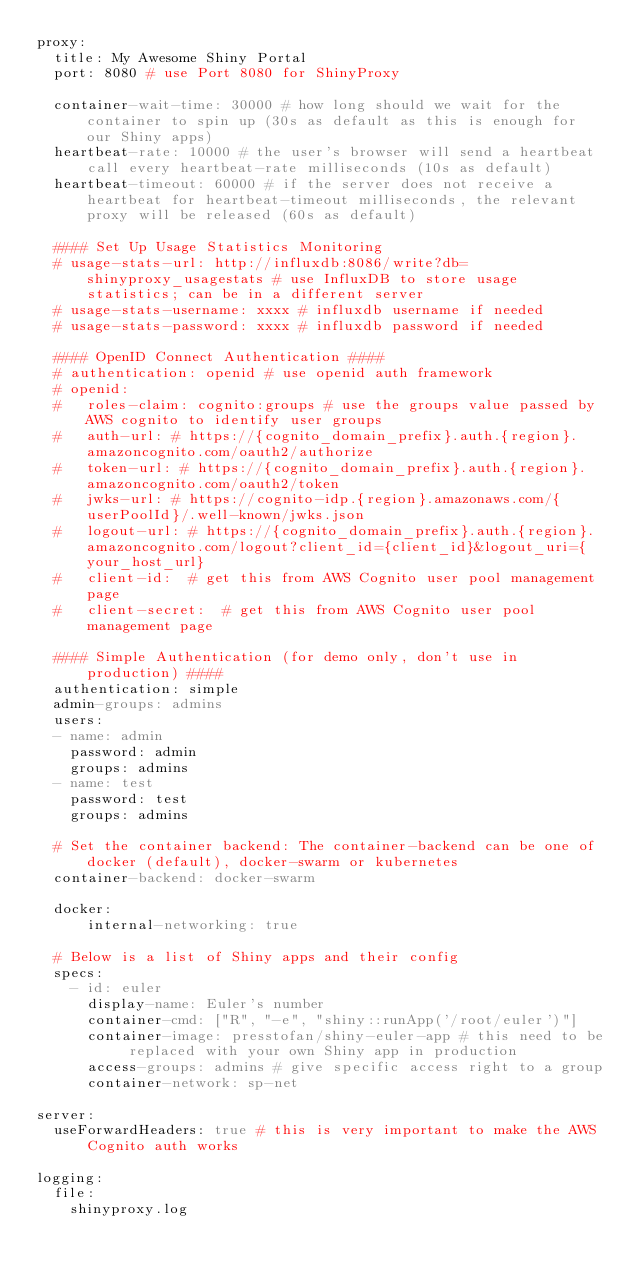<code> <loc_0><loc_0><loc_500><loc_500><_YAML_>proxy:
  title: My Awesome Shiny Portal
  port: 8080 # use Port 8080 for ShinyProxy
  
  container-wait-time: 30000 # how long should we wait for the container to spin up (30s as default as this is enough for our Shiny apps)
  heartbeat-rate: 10000 # the user's browser will send a heartbeat call every heartbeat-rate milliseconds (10s as default)
  heartbeat-timeout: 60000 # if the server does not receive a heartbeat for heartbeat-timeout milliseconds, the relevant proxy will be released (60s as default)

  #### Set Up Usage Statistics Monitoring
  # usage-stats-url: http://influxdb:8086/write?db=shinyproxy_usagestats # use InfluxDB to store usage statistics; can be in a different server
  # usage-stats-username: xxxx # influxdb username if needed
  # usage-stats-password: xxxx # influxdb password if needed

  #### OpenID Connect Authentication ####
  # authentication: openid # use openid auth framework
  # openid:
  #   roles-claim: cognito:groups # use the groups value passed by AWS cognito to identify user groups
  #   auth-url: # https://{cognito_domain_prefix}.auth.{region}.amazoncognito.com/oauth2/authorize
  #   token-url: # https://{cognito_domain_prefix}.auth.{region}.amazoncognito.com/oauth2/token
  #   jwks-url: # https://cognito-idp.{region}.amazonaws.com/{userPoolId}/.well-known/jwks.json
  #   logout-url: # https://{cognito_domain_prefix}.auth.{region}.amazoncognito.com/logout?client_id={client_id}&logout_uri={your_host_url}
  #   client-id:  # get this from AWS Cognito user pool management page
  #   client-secret:  # get this from AWS Cognito user pool management page
  
  #### Simple Authentication (for demo only, don't use in production) ####
  authentication: simple
  admin-groups: admins
  users:
  - name: admin
    password: admin
    groups: admins
  - name: test
    password: test
    groups: admins
  
  # Set the container backend: The container-backend can be one of docker (default), docker-swarm or kubernetes
  container-backend: docker-swarm
  
  docker:
      internal-networking: true
  
  # Below is a list of Shiny apps and their config
  specs:
    - id: euler
      display-name: Euler's number
      container-cmd: ["R", "-e", "shiny::runApp('/root/euler')"]
      container-image: presstofan/shiny-euler-app # this need to be replaced with your own Shiny app in production
      access-groups: admins # give specific access right to a group
      container-network: sp-net

server:
  useForwardHeaders: true # this is very important to make the AWS Cognito auth works

logging:
  file:
    shinyproxy.log</code> 